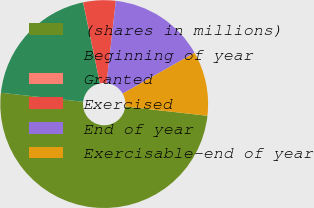Convert chart. <chart><loc_0><loc_0><loc_500><loc_500><pie_chart><fcel>(shares in millions)<fcel>Beginning of year<fcel>Granted<fcel>Exercised<fcel>End of year<fcel>Exercisable-end of year<nl><fcel>49.95%<fcel>20.0%<fcel>0.02%<fcel>5.02%<fcel>15.0%<fcel>10.01%<nl></chart> 